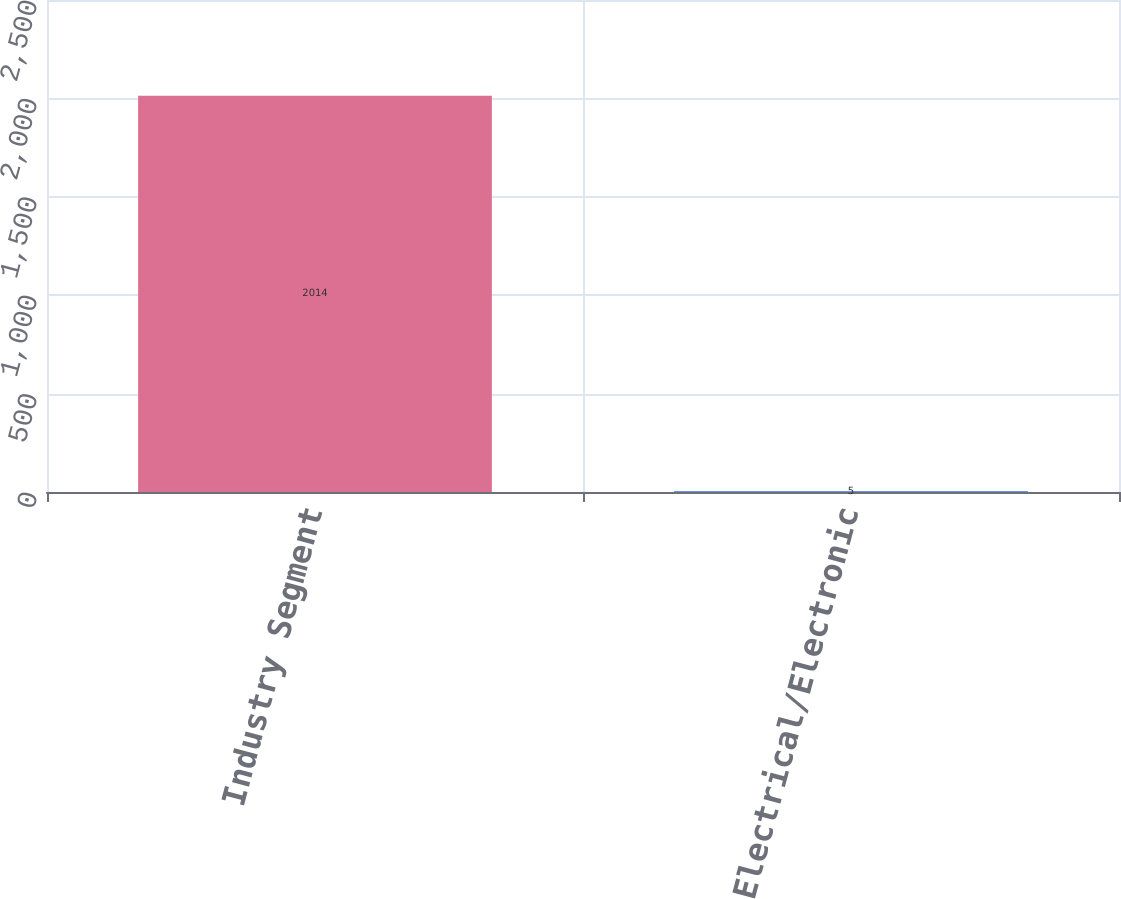Convert chart to OTSL. <chart><loc_0><loc_0><loc_500><loc_500><bar_chart><fcel>Industry Segment<fcel>Electrical/Electronic<nl><fcel>2014<fcel>5<nl></chart> 